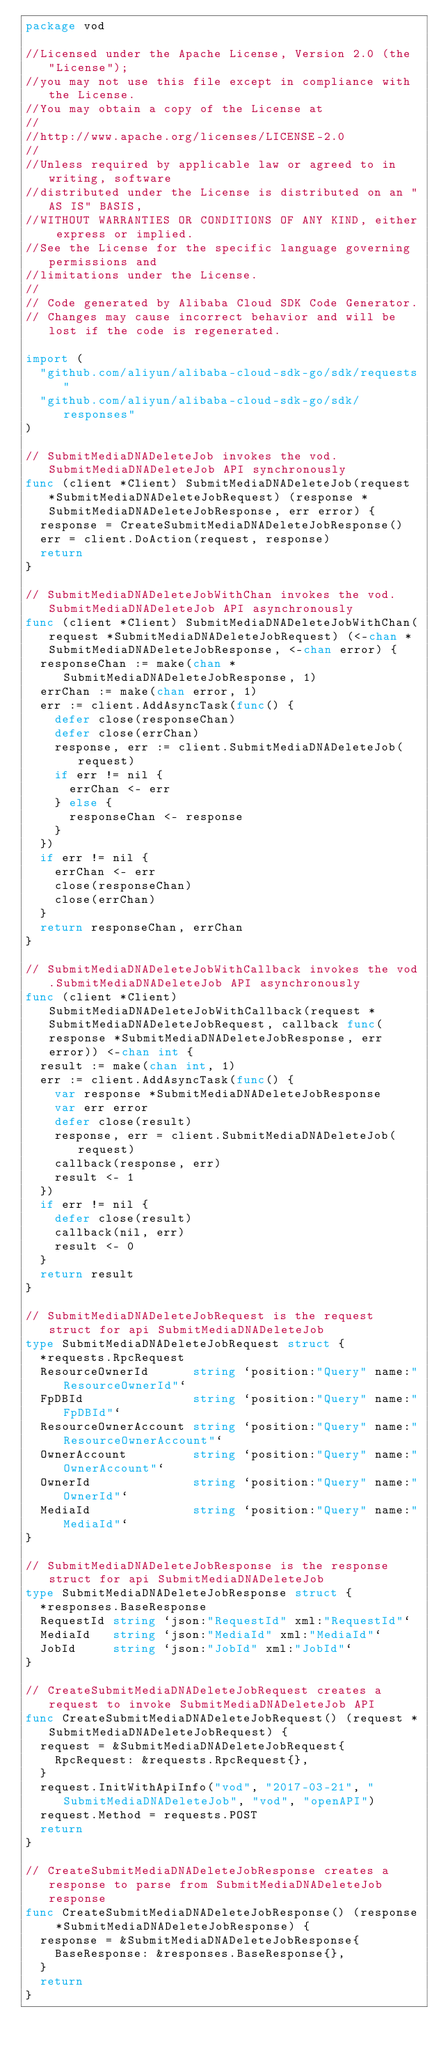<code> <loc_0><loc_0><loc_500><loc_500><_Go_>package vod

//Licensed under the Apache License, Version 2.0 (the "License");
//you may not use this file except in compliance with the License.
//You may obtain a copy of the License at
//
//http://www.apache.org/licenses/LICENSE-2.0
//
//Unless required by applicable law or agreed to in writing, software
//distributed under the License is distributed on an "AS IS" BASIS,
//WITHOUT WARRANTIES OR CONDITIONS OF ANY KIND, either express or implied.
//See the License for the specific language governing permissions and
//limitations under the License.
//
// Code generated by Alibaba Cloud SDK Code Generator.
// Changes may cause incorrect behavior and will be lost if the code is regenerated.

import (
	"github.com/aliyun/alibaba-cloud-sdk-go/sdk/requests"
	"github.com/aliyun/alibaba-cloud-sdk-go/sdk/responses"
)

// SubmitMediaDNADeleteJob invokes the vod.SubmitMediaDNADeleteJob API synchronously
func (client *Client) SubmitMediaDNADeleteJob(request *SubmitMediaDNADeleteJobRequest) (response *SubmitMediaDNADeleteJobResponse, err error) {
	response = CreateSubmitMediaDNADeleteJobResponse()
	err = client.DoAction(request, response)
	return
}

// SubmitMediaDNADeleteJobWithChan invokes the vod.SubmitMediaDNADeleteJob API asynchronously
func (client *Client) SubmitMediaDNADeleteJobWithChan(request *SubmitMediaDNADeleteJobRequest) (<-chan *SubmitMediaDNADeleteJobResponse, <-chan error) {
	responseChan := make(chan *SubmitMediaDNADeleteJobResponse, 1)
	errChan := make(chan error, 1)
	err := client.AddAsyncTask(func() {
		defer close(responseChan)
		defer close(errChan)
		response, err := client.SubmitMediaDNADeleteJob(request)
		if err != nil {
			errChan <- err
		} else {
			responseChan <- response
		}
	})
	if err != nil {
		errChan <- err
		close(responseChan)
		close(errChan)
	}
	return responseChan, errChan
}

// SubmitMediaDNADeleteJobWithCallback invokes the vod.SubmitMediaDNADeleteJob API asynchronously
func (client *Client) SubmitMediaDNADeleteJobWithCallback(request *SubmitMediaDNADeleteJobRequest, callback func(response *SubmitMediaDNADeleteJobResponse, err error)) <-chan int {
	result := make(chan int, 1)
	err := client.AddAsyncTask(func() {
		var response *SubmitMediaDNADeleteJobResponse
		var err error
		defer close(result)
		response, err = client.SubmitMediaDNADeleteJob(request)
		callback(response, err)
		result <- 1
	})
	if err != nil {
		defer close(result)
		callback(nil, err)
		result <- 0
	}
	return result
}

// SubmitMediaDNADeleteJobRequest is the request struct for api SubmitMediaDNADeleteJob
type SubmitMediaDNADeleteJobRequest struct {
	*requests.RpcRequest
	ResourceOwnerId      string `position:"Query" name:"ResourceOwnerId"`
	FpDBId               string `position:"Query" name:"FpDBId"`
	ResourceOwnerAccount string `position:"Query" name:"ResourceOwnerAccount"`
	OwnerAccount         string `position:"Query" name:"OwnerAccount"`
	OwnerId              string `position:"Query" name:"OwnerId"`
	MediaId              string `position:"Query" name:"MediaId"`
}

// SubmitMediaDNADeleteJobResponse is the response struct for api SubmitMediaDNADeleteJob
type SubmitMediaDNADeleteJobResponse struct {
	*responses.BaseResponse
	RequestId string `json:"RequestId" xml:"RequestId"`
	MediaId   string `json:"MediaId" xml:"MediaId"`
	JobId     string `json:"JobId" xml:"JobId"`
}

// CreateSubmitMediaDNADeleteJobRequest creates a request to invoke SubmitMediaDNADeleteJob API
func CreateSubmitMediaDNADeleteJobRequest() (request *SubmitMediaDNADeleteJobRequest) {
	request = &SubmitMediaDNADeleteJobRequest{
		RpcRequest: &requests.RpcRequest{},
	}
	request.InitWithApiInfo("vod", "2017-03-21", "SubmitMediaDNADeleteJob", "vod", "openAPI")
	request.Method = requests.POST
	return
}

// CreateSubmitMediaDNADeleteJobResponse creates a response to parse from SubmitMediaDNADeleteJob response
func CreateSubmitMediaDNADeleteJobResponse() (response *SubmitMediaDNADeleteJobResponse) {
	response = &SubmitMediaDNADeleteJobResponse{
		BaseResponse: &responses.BaseResponse{},
	}
	return
}
</code> 